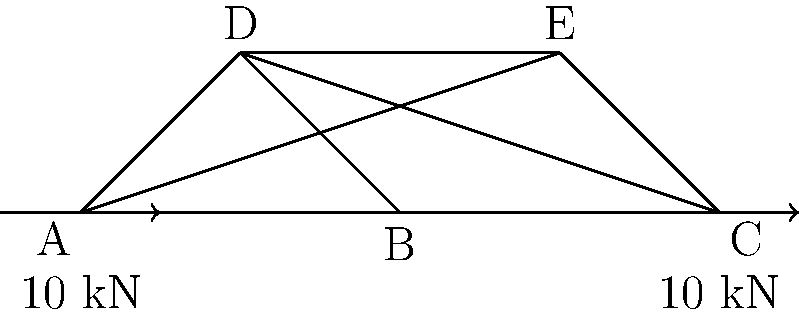During a long road trip, your partner recommends a book about bridge engineering. Inspired, you decide to analyze a simple truss bridge design. The truss diagram above represents a section of the bridge, with two 10 kN loads applied at points A and C. Assuming the truss is in equilibrium, determine the force in member BE. Is it in tension or compression? Let's approach this step-by-step:

1) First, we need to determine the reactions at the supports. Given the symmetry of the structure and loading, we can conclude that the reaction at E is 10 kN upward.

2) Now, let's focus on joint B. We know three forces act on this joint: the force in BE, the force in BD, and the force in AB.

3) We can use the method of joints to analyze the forces at B. Let's resolve forces in the vertical and horizontal directions.

4) Vertical equilibrium at B:
   $$F_{BD} \sin 45° = 10 \text{ kN}$$
   $$F_{BD} = 10 \sqrt{2} \text{ kN}$$

5) Horizontal equilibrium at B:
   $$F_{BE} + F_{BD} \cos 45° = 0$$
   $$F_{BE} = -F_{BD} \cos 45° = -10 \text{ kN}$$

6) The negative sign indicates that the force in BE is compressive.

7) We can verify this result by considering the overall structure. The external loads tend to push points A and C downwards, which would cause point B to move upwards. This upward movement is resisted by member BE, putting it in compression.
Answer: 10 kN, compression 